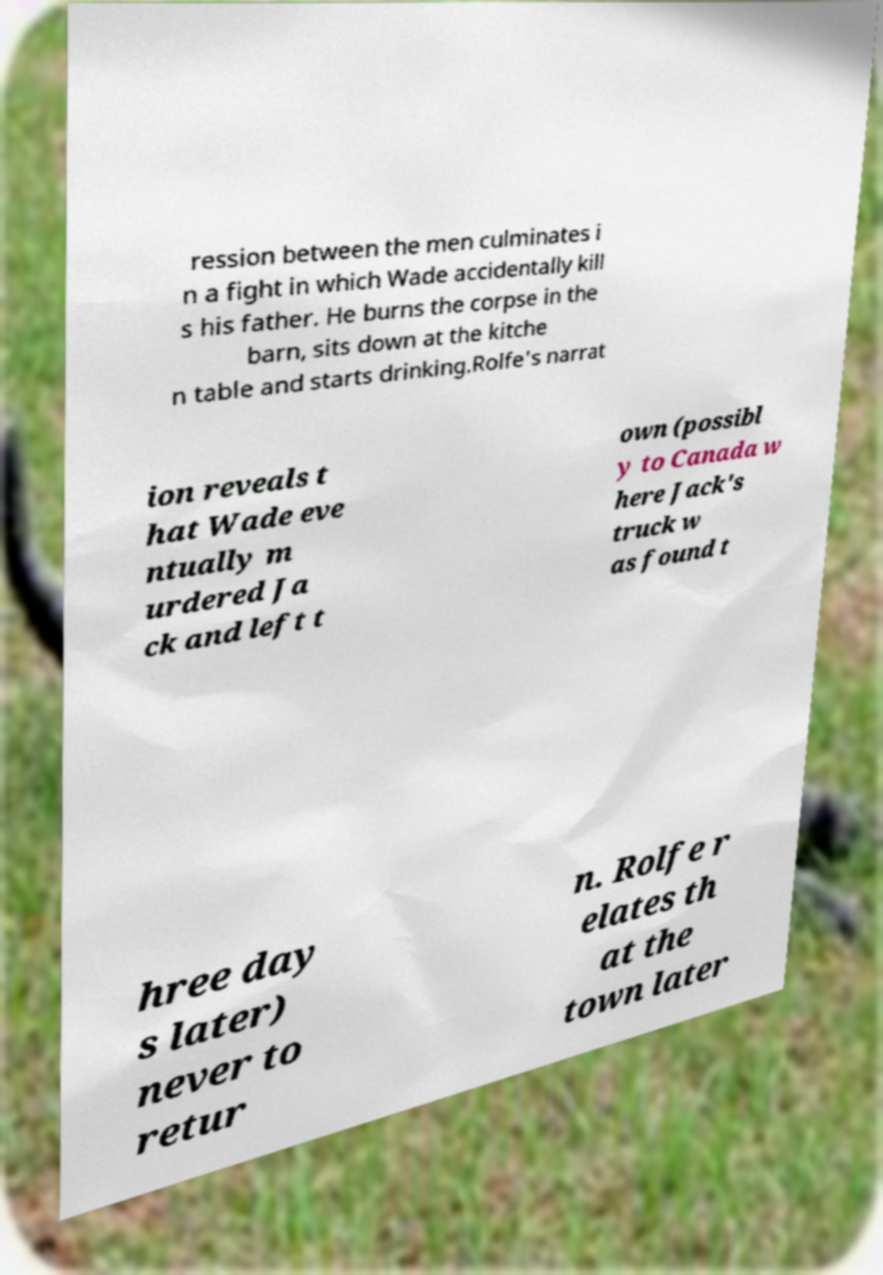Could you extract and type out the text from this image? ression between the men culminates i n a fight in which Wade accidentally kill s his father. He burns the corpse in the barn, sits down at the kitche n table and starts drinking.Rolfe's narrat ion reveals t hat Wade eve ntually m urdered Ja ck and left t own (possibl y to Canada w here Jack's truck w as found t hree day s later) never to retur n. Rolfe r elates th at the town later 